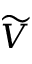Convert formula to latex. <formula><loc_0><loc_0><loc_500><loc_500>\widetilde { V }</formula> 